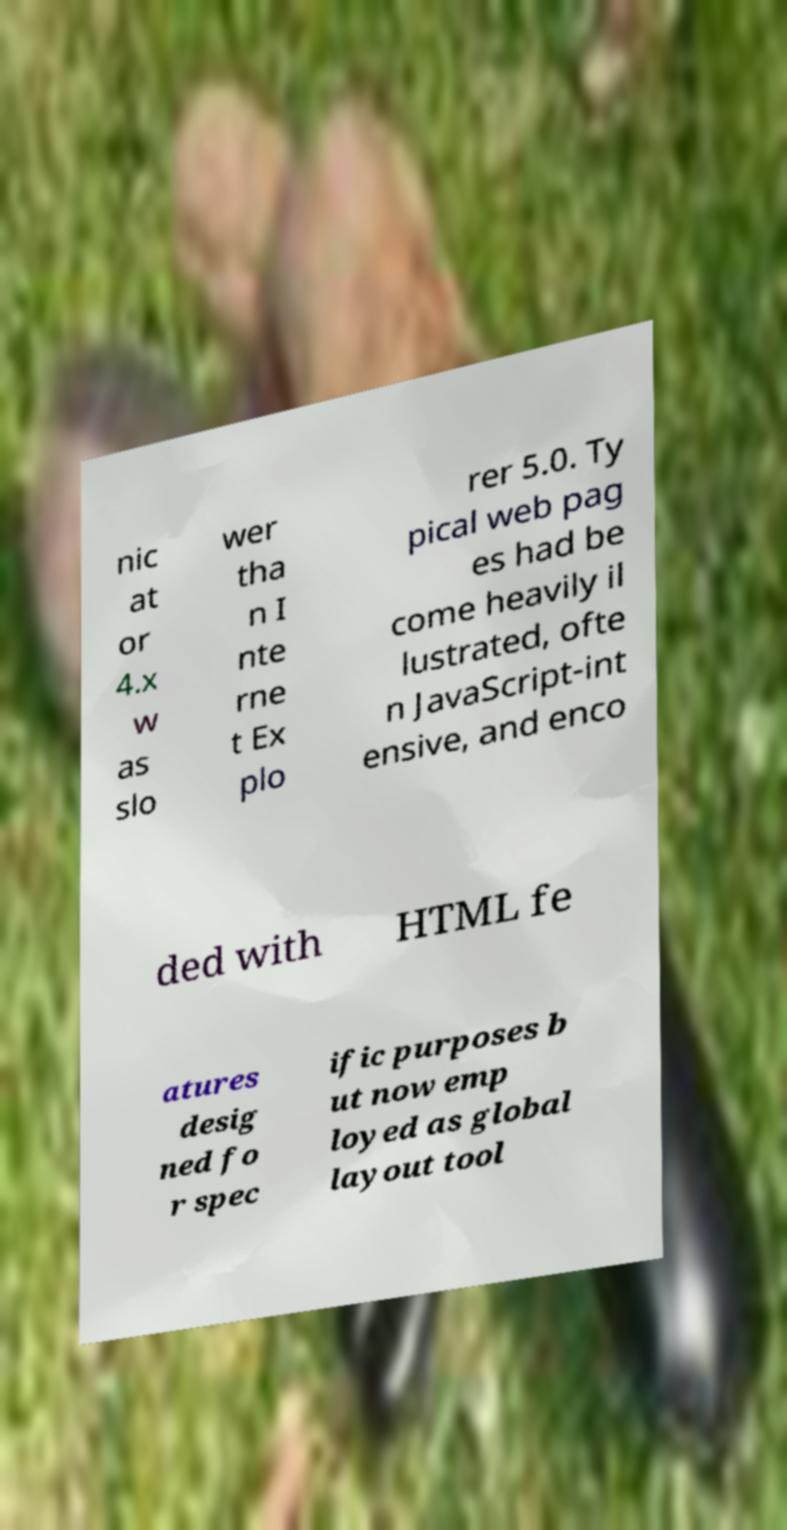For documentation purposes, I need the text within this image transcribed. Could you provide that? nic at or 4.x w as slo wer tha n I nte rne t Ex plo rer 5.0. Ty pical web pag es had be come heavily il lustrated, ofte n JavaScript-int ensive, and enco ded with HTML fe atures desig ned fo r spec ific purposes b ut now emp loyed as global layout tool 